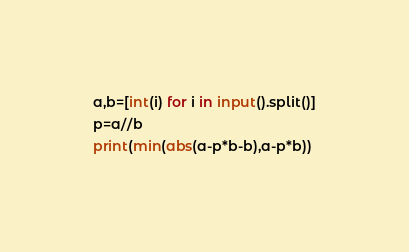<code> <loc_0><loc_0><loc_500><loc_500><_Python_>a,b=[int(i) for i in input().split()]
p=a//b
print(min(abs(a-p*b-b),a-p*b))
</code> 